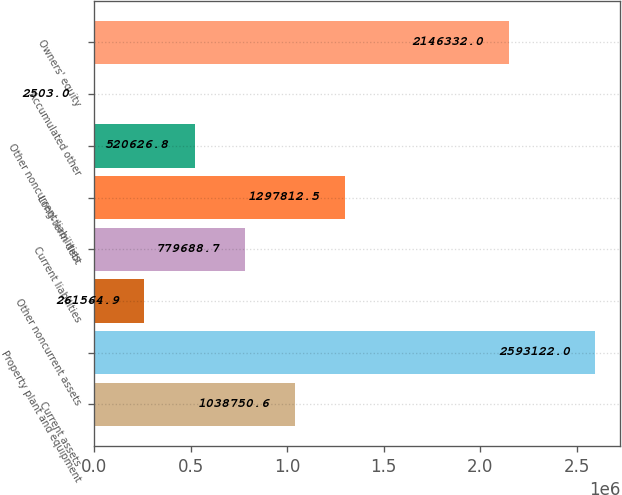Convert chart to OTSL. <chart><loc_0><loc_0><loc_500><loc_500><bar_chart><fcel>Current assets<fcel>Property plant and equipment<fcel>Other noncurrent assets<fcel>Current liabilities<fcel>Long-term debt<fcel>Other noncurrent liabilities<fcel>Accumulated other<fcel>Owners' equity<nl><fcel>1.03875e+06<fcel>2.59312e+06<fcel>261565<fcel>779689<fcel>1.29781e+06<fcel>520627<fcel>2503<fcel>2.14633e+06<nl></chart> 